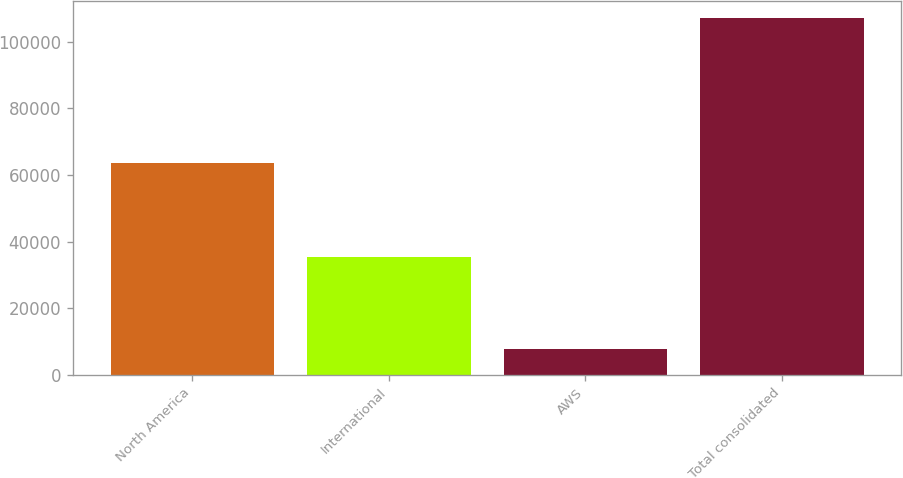<chart> <loc_0><loc_0><loc_500><loc_500><bar_chart><fcel>North America<fcel>International<fcel>AWS<fcel>Total consolidated<nl><fcel>63708<fcel>35418<fcel>7880<fcel>107006<nl></chart> 